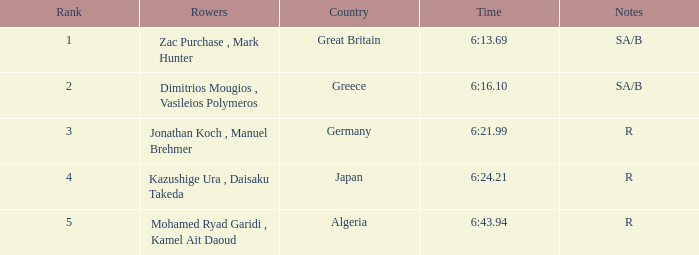21? R. 